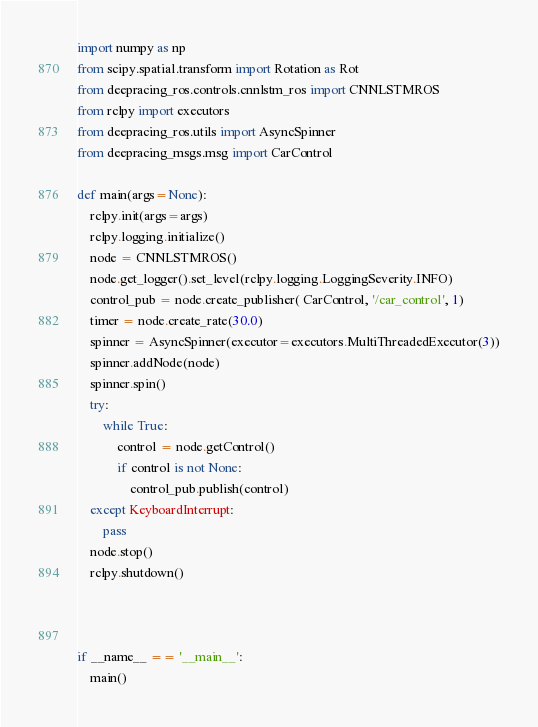Convert code to text. <code><loc_0><loc_0><loc_500><loc_500><_Python_>import numpy as np
from scipy.spatial.transform import Rotation as Rot
from deepracing_ros.controls.cnnlstm_ros import CNNLSTMROS
from rclpy import executors
from deepracing_ros.utils import AsyncSpinner
from deepracing_msgs.msg import CarControl

def main(args=None):
    rclpy.init(args=args)
    rclpy.logging.initialize()
    node = CNNLSTMROS()
    node.get_logger().set_level(rclpy.logging.LoggingSeverity.INFO)
    control_pub = node.create_publisher( CarControl, '/car_control', 1)
    timer = node.create_rate(30.0)
    spinner = AsyncSpinner(executor=executors.MultiThreadedExecutor(3))
    spinner.addNode(node)
    spinner.spin()
    try:
        while True:
            control = node.getControl()
            if control is not None:
                control_pub.publish(control)
    except KeyboardInterrupt:
        pass
    node.stop()
    rclpy.shutdown()
    


if __name__ == '__main__':
    main()</code> 